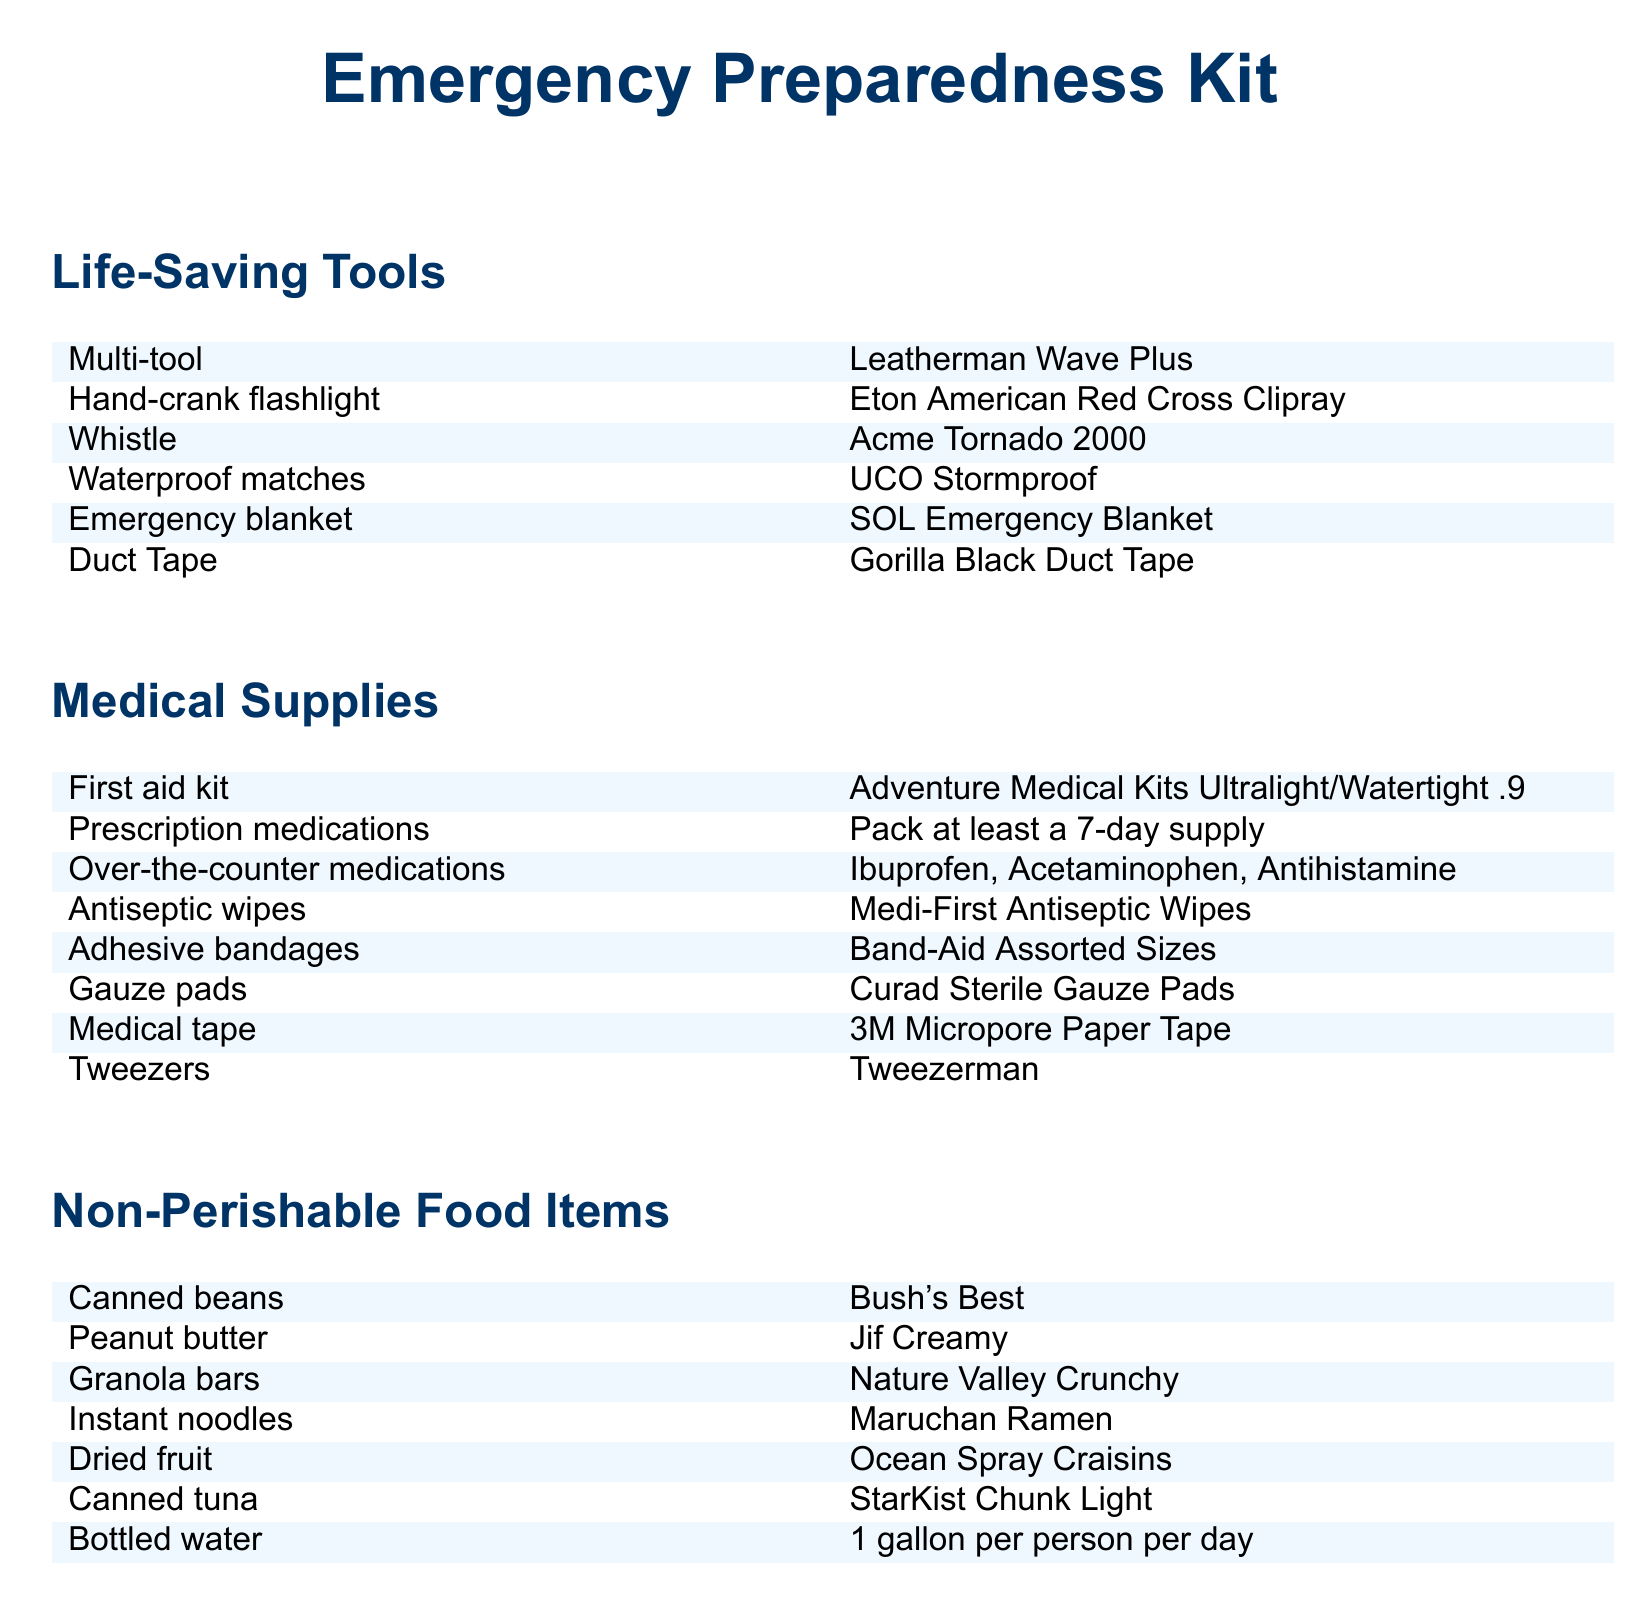What is the first item listed under Life-Saving Tools? The first item listed is the Multi-tool.
Answer: Multi-tool How many prescription medication supplies should be packed? It mentions packing at least a 7-day supply.
Answer: 7-day supply What type of non-perishable food item is listed first? The first listed non-perishable food item is canned beans.
Answer: Canned beans Name one type of adhesive bandage mentioned in the Medical Supplies section. The document specifies Band-Aid Assorted Sizes.
Answer: Band-Aid Assorted Sizes Which brand of canned tuna is included in the list? The brand of canned tuna included is StarKist Chunk Light.
Answer: StarKist Chunk Light How many gallons of bottled water is recommended per person per day? The recommendation is for 1 gallon of bottled water per person per day.
Answer: 1 gallon What type of flashlight is suggested in the Emergency Preparedness Kit? The document suggests a hand-crank flashlight.
Answer: Hand-crank flashlight What is the function of the emergency blanket mentioned? The emergency blanket provides thermal protection.
Answer: Thermal protection 